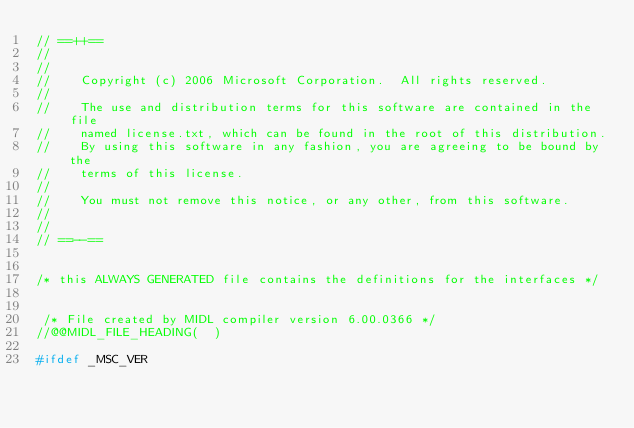Convert code to text. <code><loc_0><loc_0><loc_500><loc_500><_C_>// ==++==
//
//   
//    Copyright (c) 2006 Microsoft Corporation.  All rights reserved.
//   
//    The use and distribution terms for this software are contained in the file
//    named license.txt, which can be found in the root of this distribution.
//    By using this software in any fashion, you are agreeing to be bound by the
//    terms of this license.
//   
//    You must not remove this notice, or any other, from this software.
//   
//
// ==--==


/* this ALWAYS GENERATED file contains the definitions for the interfaces */


 /* File created by MIDL compiler version 6.00.0366 */
//@@MIDL_FILE_HEADING(  )

#ifdef _MSC_VER</code> 